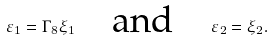<formula> <loc_0><loc_0><loc_500><loc_500>\varepsilon _ { 1 } = \Gamma _ { 8 } \xi _ { 1 } \quad \text {and} \quad \varepsilon _ { 2 } = \xi _ { 2 } .</formula> 